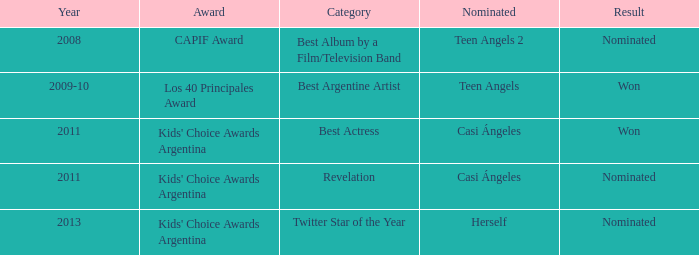What year was Teen Angels 2 nominated? 2008.0. Would you mind parsing the complete table? {'header': ['Year', 'Award', 'Category', 'Nominated', 'Result'], 'rows': [['2008', 'CAPIF Award', 'Best Album by a Film/Television Band', 'Teen Angels 2', 'Nominated'], ['2009-10', 'Los 40 Principales Award', 'Best Argentine Artist', 'Teen Angels', 'Won'], ['2011', "Kids' Choice Awards Argentina", 'Best Actress', 'Casi Ángeles', 'Won'], ['2011', "Kids' Choice Awards Argentina", 'Revelation', 'Casi Ángeles', 'Nominated'], ['2013', "Kids' Choice Awards Argentina", 'Twitter Star of the Year', 'Herself', 'Nominated']]} 